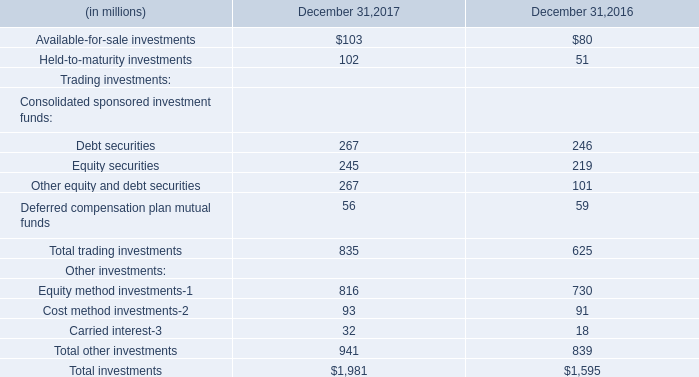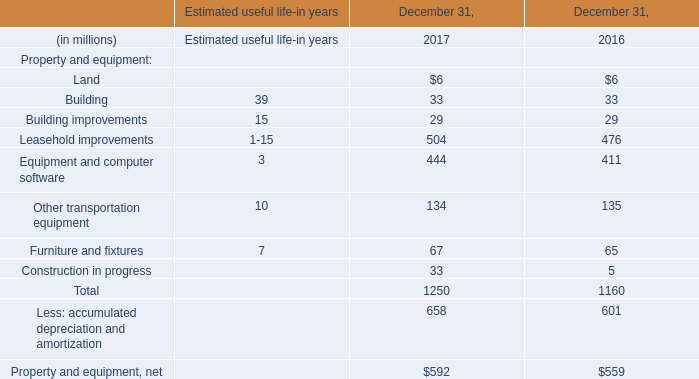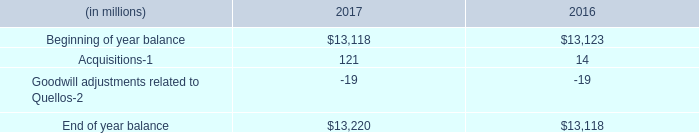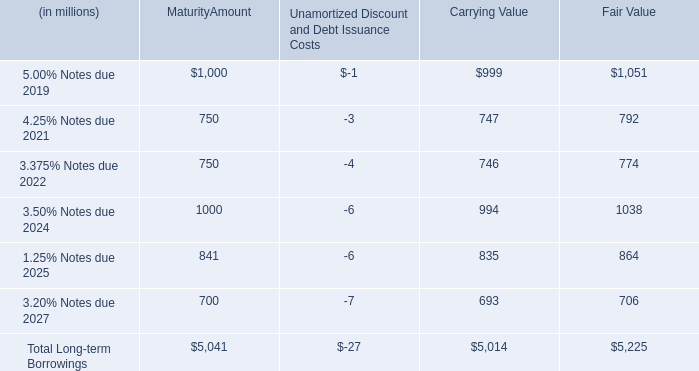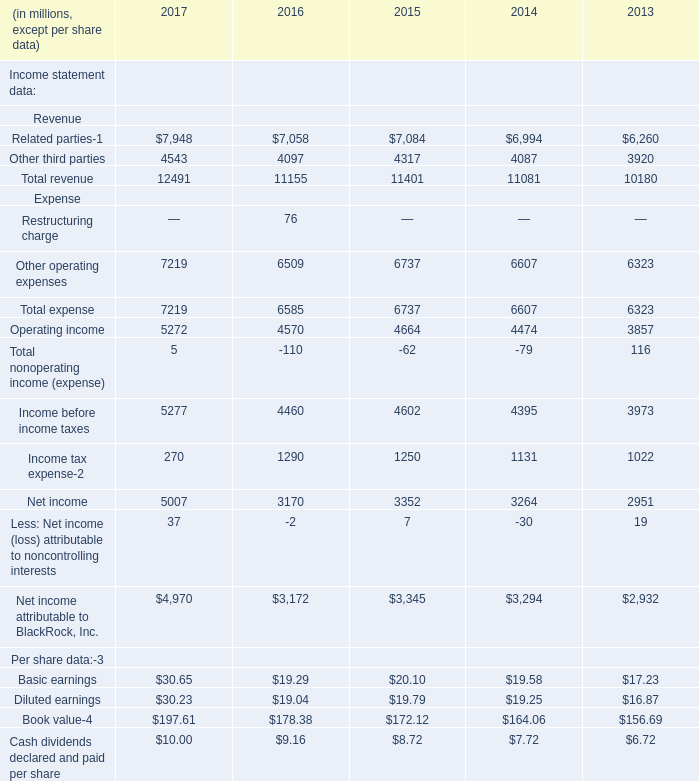what's the total amount of Related parties of 2017, Beginning of year balance of 2017, and Net income Expense of 2017 ? 
Computations: ((7948.0 + 13118.0) + 5007.0)
Answer: 26073.0. 